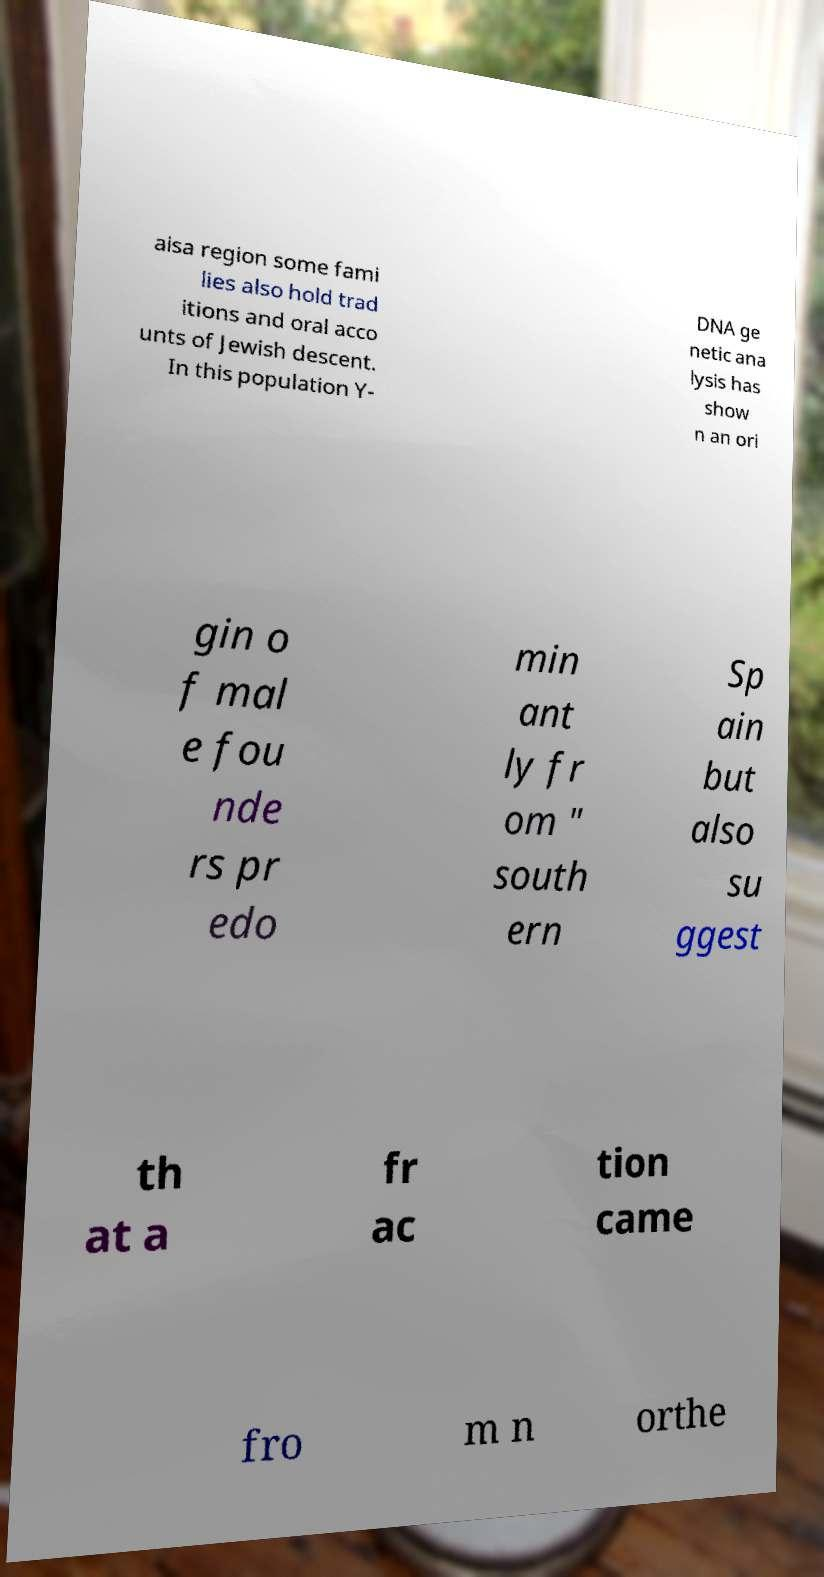Can you accurately transcribe the text from the provided image for me? aisa region some fami lies also hold trad itions and oral acco unts of Jewish descent. In this population Y- DNA ge netic ana lysis has show n an ori gin o f mal e fou nde rs pr edo min ant ly fr om " south ern Sp ain but also su ggest th at a fr ac tion came fro m n orthe 